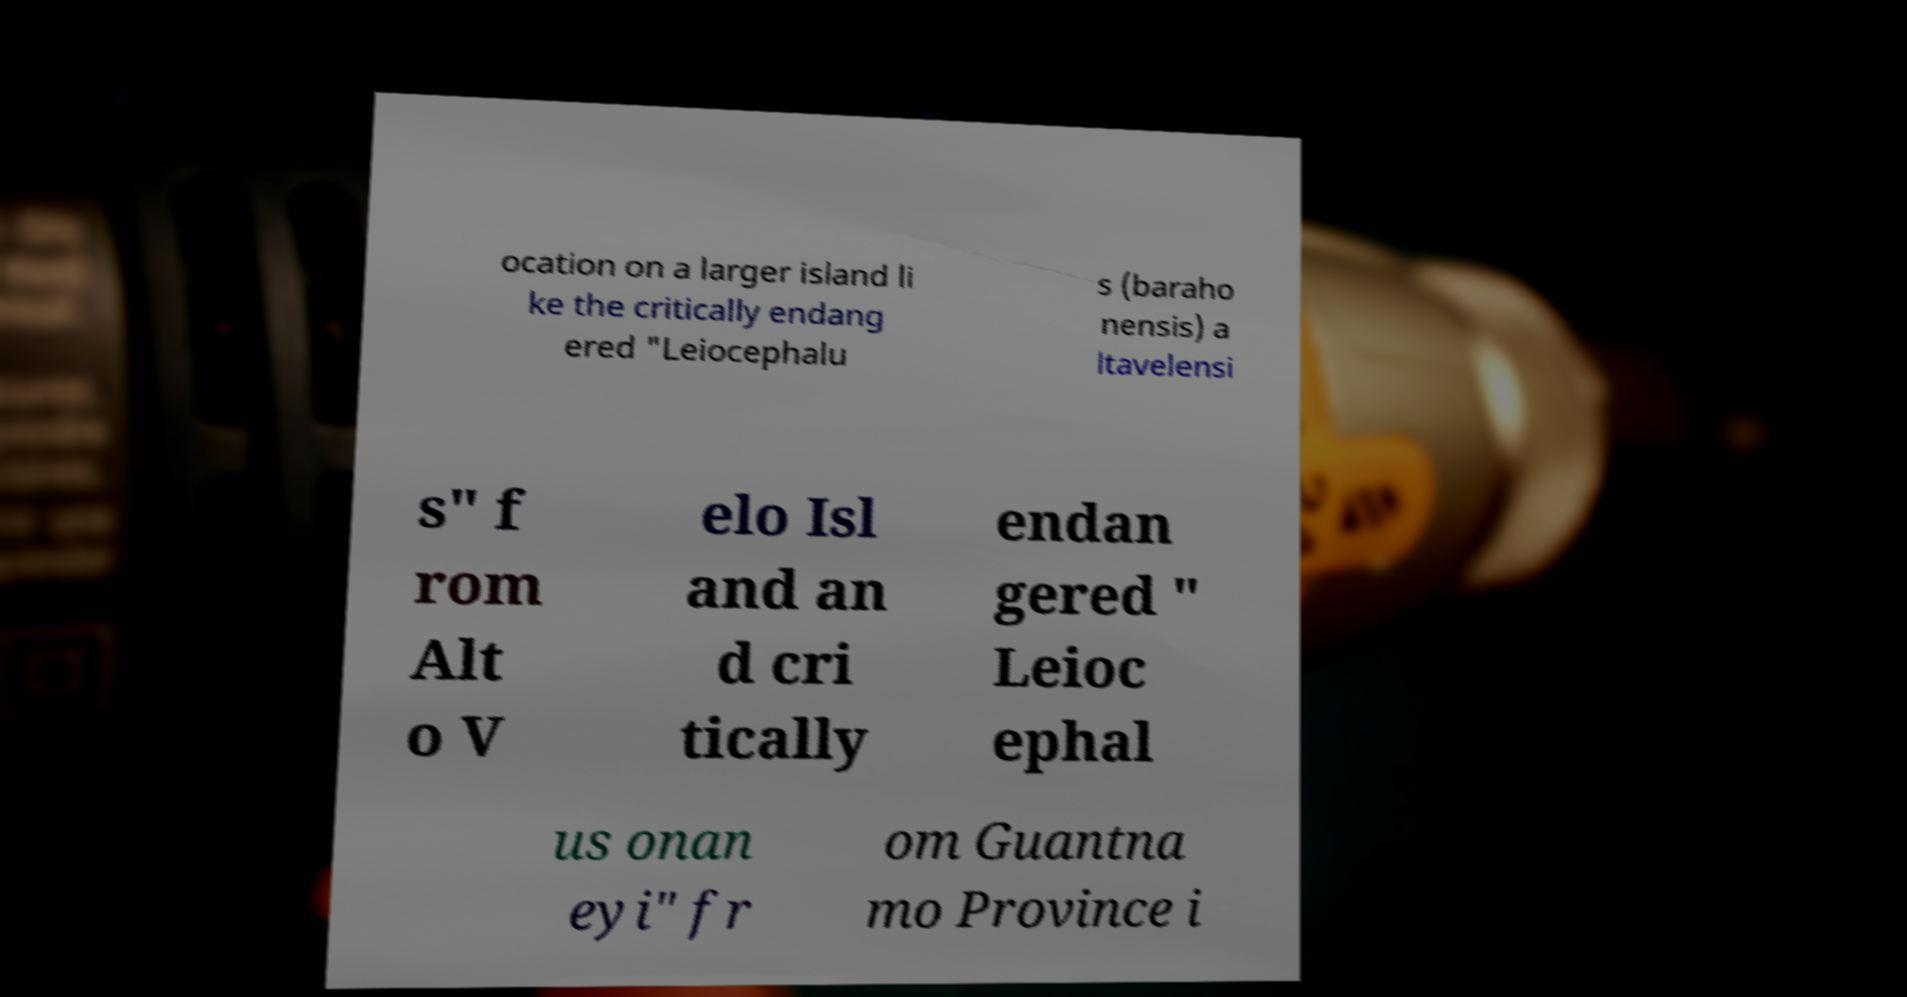Can you accurately transcribe the text from the provided image for me? ocation on a larger island li ke the critically endang ered "Leiocephalu s (baraho nensis) a ltavelensi s" f rom Alt o V elo Isl and an d cri tically endan gered " Leioc ephal us onan eyi" fr om Guantna mo Province i 